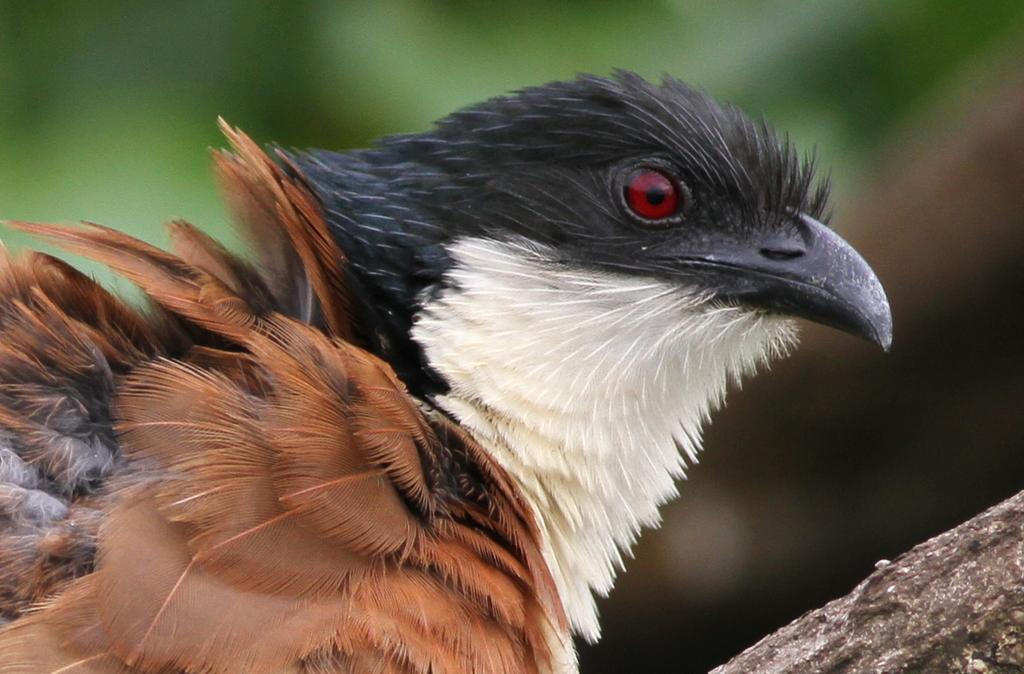What type of animal is in the image? There is a bird in the image. Can you describe the colors of the bird? The bird has black, white, and brown colors. What can be seen in the background of the image? The background of the image is green. What type of cracker is the bird holding in its beak in the image? There is no cracker present in the image; the bird is not holding anything in its beak. 